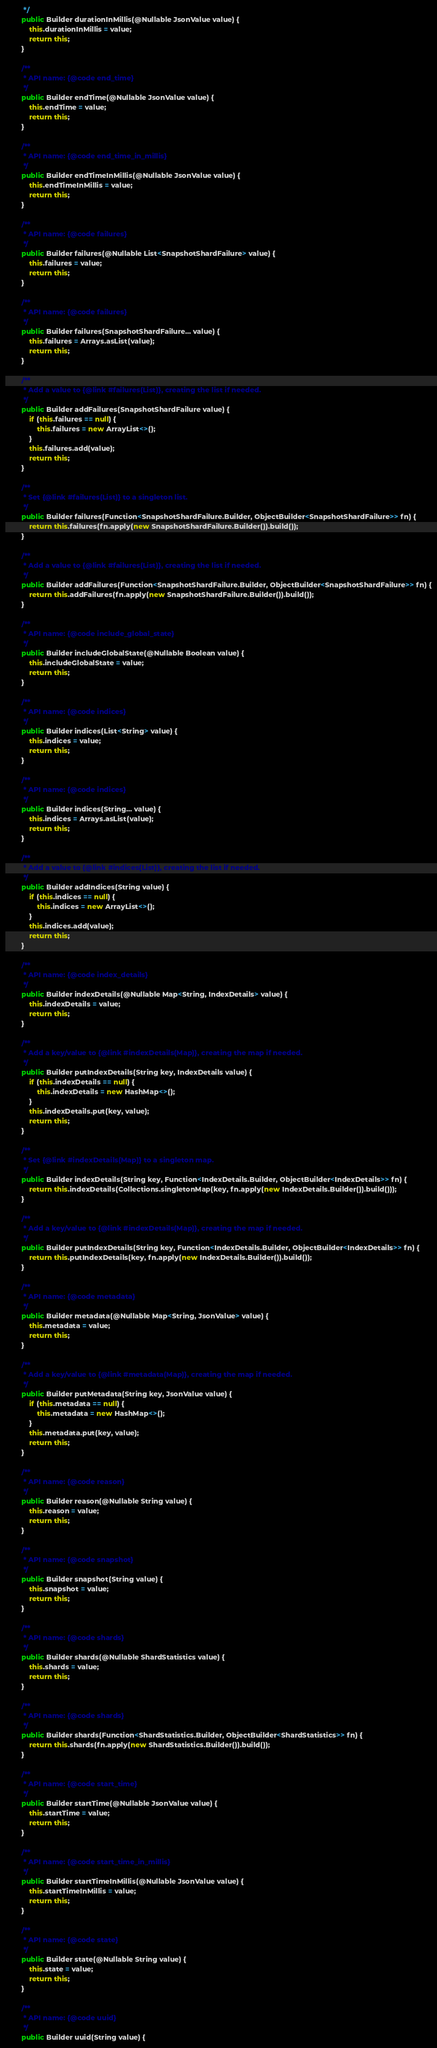Convert code to text. <code><loc_0><loc_0><loc_500><loc_500><_Java_>		 */
		public Builder durationInMillis(@Nullable JsonValue value) {
			this.durationInMillis = value;
			return this;
		}

		/**
		 * API name: {@code end_time}
		 */
		public Builder endTime(@Nullable JsonValue value) {
			this.endTime = value;
			return this;
		}

		/**
		 * API name: {@code end_time_in_millis}
		 */
		public Builder endTimeInMillis(@Nullable JsonValue value) {
			this.endTimeInMillis = value;
			return this;
		}

		/**
		 * API name: {@code failures}
		 */
		public Builder failures(@Nullable List<SnapshotShardFailure> value) {
			this.failures = value;
			return this;
		}

		/**
		 * API name: {@code failures}
		 */
		public Builder failures(SnapshotShardFailure... value) {
			this.failures = Arrays.asList(value);
			return this;
		}

		/**
		 * Add a value to {@link #failures(List)}, creating the list if needed.
		 */
		public Builder addFailures(SnapshotShardFailure value) {
			if (this.failures == null) {
				this.failures = new ArrayList<>();
			}
			this.failures.add(value);
			return this;
		}

		/**
		 * Set {@link #failures(List)} to a singleton list.
		 */
		public Builder failures(Function<SnapshotShardFailure.Builder, ObjectBuilder<SnapshotShardFailure>> fn) {
			return this.failures(fn.apply(new SnapshotShardFailure.Builder()).build());
		}

		/**
		 * Add a value to {@link #failures(List)}, creating the list if needed.
		 */
		public Builder addFailures(Function<SnapshotShardFailure.Builder, ObjectBuilder<SnapshotShardFailure>> fn) {
			return this.addFailures(fn.apply(new SnapshotShardFailure.Builder()).build());
		}

		/**
		 * API name: {@code include_global_state}
		 */
		public Builder includeGlobalState(@Nullable Boolean value) {
			this.includeGlobalState = value;
			return this;
		}

		/**
		 * API name: {@code indices}
		 */
		public Builder indices(List<String> value) {
			this.indices = value;
			return this;
		}

		/**
		 * API name: {@code indices}
		 */
		public Builder indices(String... value) {
			this.indices = Arrays.asList(value);
			return this;
		}

		/**
		 * Add a value to {@link #indices(List)}, creating the list if needed.
		 */
		public Builder addIndices(String value) {
			if (this.indices == null) {
				this.indices = new ArrayList<>();
			}
			this.indices.add(value);
			return this;
		}

		/**
		 * API name: {@code index_details}
		 */
		public Builder indexDetails(@Nullable Map<String, IndexDetails> value) {
			this.indexDetails = value;
			return this;
		}

		/**
		 * Add a key/value to {@link #indexDetails(Map)}, creating the map if needed.
		 */
		public Builder putIndexDetails(String key, IndexDetails value) {
			if (this.indexDetails == null) {
				this.indexDetails = new HashMap<>();
			}
			this.indexDetails.put(key, value);
			return this;
		}

		/**
		 * Set {@link #indexDetails(Map)} to a singleton map.
		 */
		public Builder indexDetails(String key, Function<IndexDetails.Builder, ObjectBuilder<IndexDetails>> fn) {
			return this.indexDetails(Collections.singletonMap(key, fn.apply(new IndexDetails.Builder()).build()));
		}

		/**
		 * Add a key/value to {@link #indexDetails(Map)}, creating the map if needed.
		 */
		public Builder putIndexDetails(String key, Function<IndexDetails.Builder, ObjectBuilder<IndexDetails>> fn) {
			return this.putIndexDetails(key, fn.apply(new IndexDetails.Builder()).build());
		}

		/**
		 * API name: {@code metadata}
		 */
		public Builder metadata(@Nullable Map<String, JsonValue> value) {
			this.metadata = value;
			return this;
		}

		/**
		 * Add a key/value to {@link #metadata(Map)}, creating the map if needed.
		 */
		public Builder putMetadata(String key, JsonValue value) {
			if (this.metadata == null) {
				this.metadata = new HashMap<>();
			}
			this.metadata.put(key, value);
			return this;
		}

		/**
		 * API name: {@code reason}
		 */
		public Builder reason(@Nullable String value) {
			this.reason = value;
			return this;
		}

		/**
		 * API name: {@code snapshot}
		 */
		public Builder snapshot(String value) {
			this.snapshot = value;
			return this;
		}

		/**
		 * API name: {@code shards}
		 */
		public Builder shards(@Nullable ShardStatistics value) {
			this.shards = value;
			return this;
		}

		/**
		 * API name: {@code shards}
		 */
		public Builder shards(Function<ShardStatistics.Builder, ObjectBuilder<ShardStatistics>> fn) {
			return this.shards(fn.apply(new ShardStatistics.Builder()).build());
		}

		/**
		 * API name: {@code start_time}
		 */
		public Builder startTime(@Nullable JsonValue value) {
			this.startTime = value;
			return this;
		}

		/**
		 * API name: {@code start_time_in_millis}
		 */
		public Builder startTimeInMillis(@Nullable JsonValue value) {
			this.startTimeInMillis = value;
			return this;
		}

		/**
		 * API name: {@code state}
		 */
		public Builder state(@Nullable String value) {
			this.state = value;
			return this;
		}

		/**
		 * API name: {@code uuid}
		 */
		public Builder uuid(String value) {</code> 